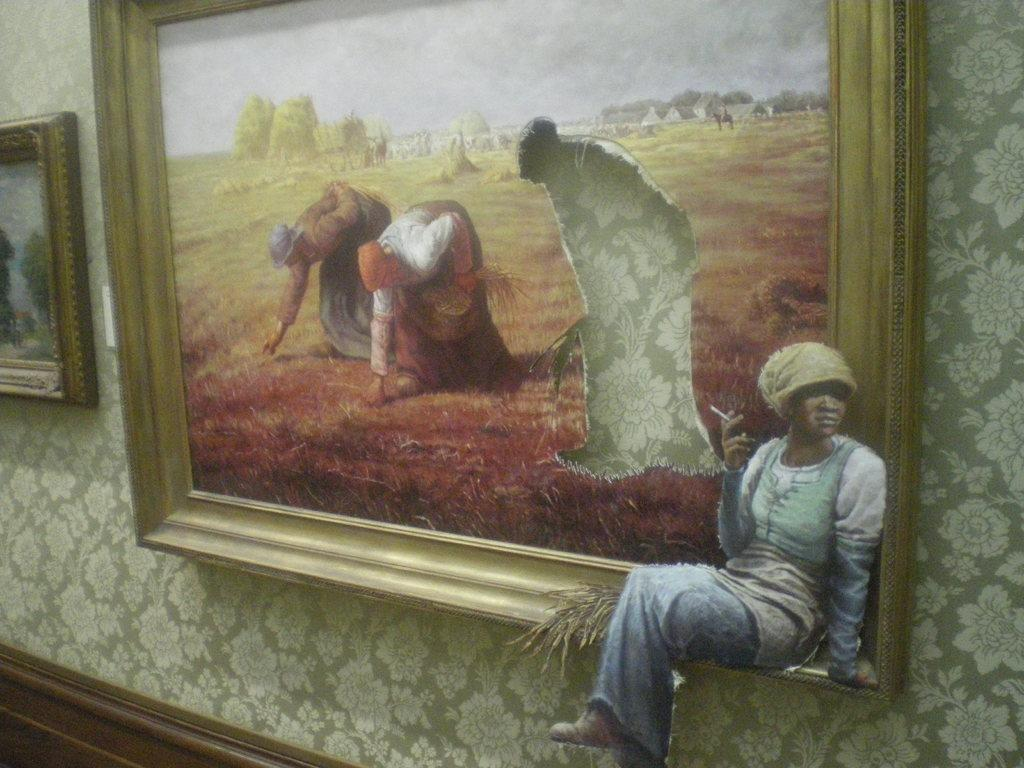What is hanging on the wall in the image? There is a photo frame on the wall containing a depiction of persons. Are there any other photo frames in the image? Yes, there is another photo frame on the left side of the image. What type of property is being developed in the image? There is no indication of any property development in the image; it primarily features photo frames. 